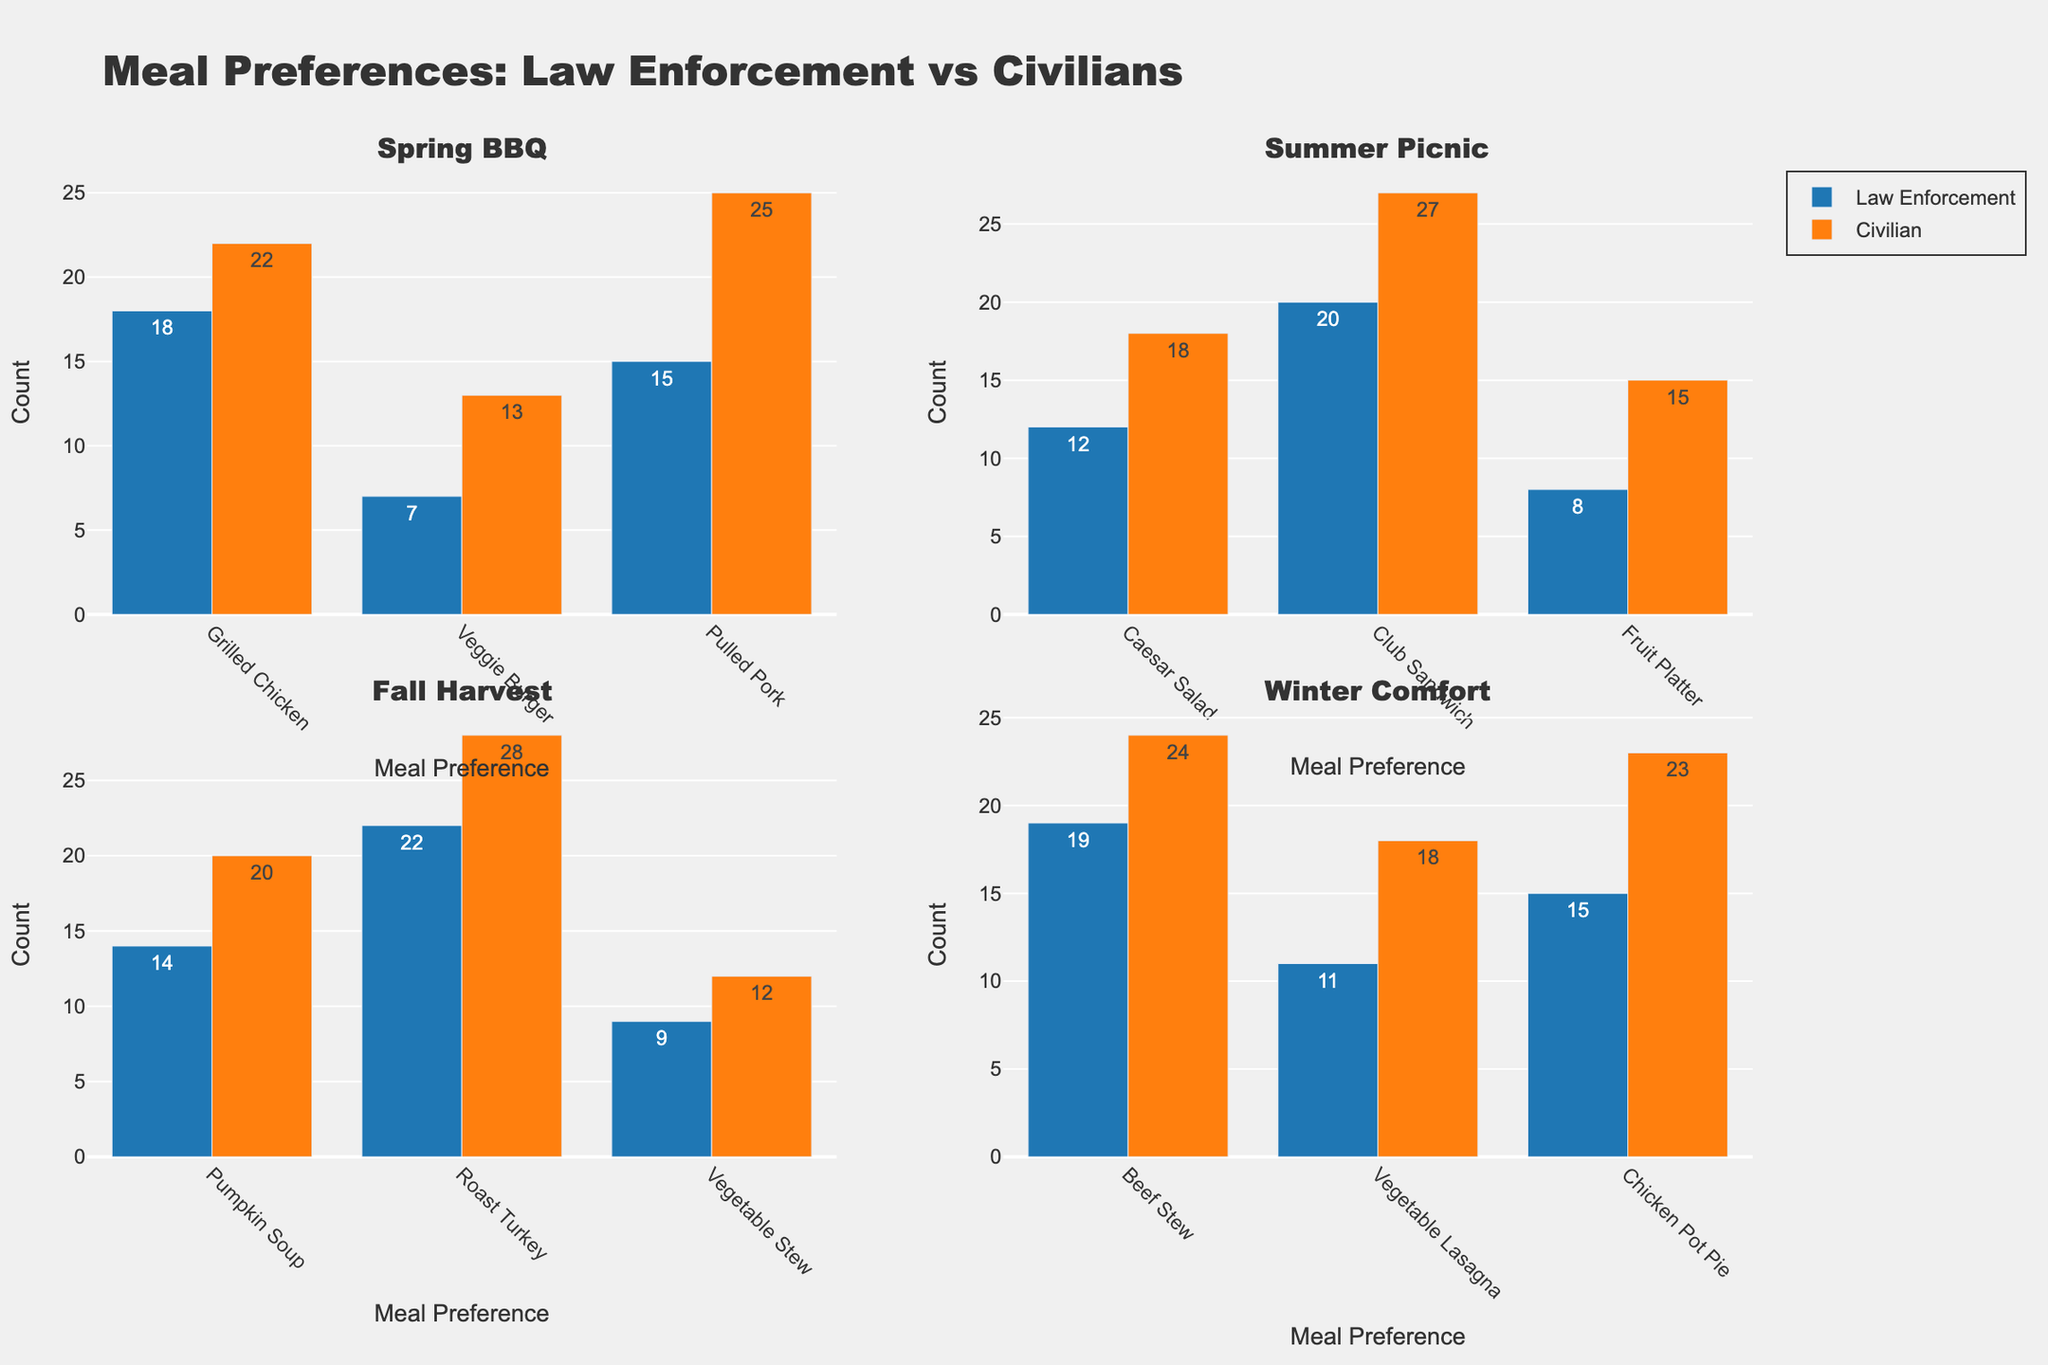What meal preference is the most popular among law enforcement at the Spring BBQ? The bar representing the number of law enforcement who preferred Pulled Pork at the Spring BBQ is the highest.
Answer: Pulled Pork What meal preference do civilians prefer the least at the Summer Picnic? The bar representing the number of civilians who preferred Fruit Platter at the Summer Picnic is the shortest.
Answer: Fruit Platter How many more civilians preferred Veggie Burger over law enforcement at the Spring BBQ? The bar for civilians' Veggie Burger preference at the Spring BBQ is 13, while the bar for law enforcement is 7. Subtract the two values: 13 - 7 = 6.
Answer: 6 Which category preferred Roast Turkey more during the Fall Harvest event? Compare the bars for Roast Turkey in the Fall Harvest event. Civilians have a higher count (28) than law enforcement (22).
Answer: Civilians During the Winter Comfort event, is the sum of civilians' preferences for Beef Stew and Chicken Pot Pie higher than the sum of law enforcement's preferences for the same meals? Civilians' preferences for Beef Stew and Chicken Pot Pie total 24 + 23 = 47. Law enforcement's preferences for the same meals total 19 + 15 = 34. 47 > 34.
Answer: Yes What is the total number of law enforcement who preferred Caesar Salad across all events? Caesar Salad preference is only listed under the Summer Picnic event where law enforcement count is 12.
Answer: 12 Which event had the highest count for a single meal preference category among civilians? Compare the highest meal preference counts among civilians across all events: Spring BBQ (Pulled Pork - 25), Summer Picnic (Club Sandwich - 27), Fall Harvest (Roast Turkey - 28), Winter Comfort (Beef Stew - 24). The highest value is 28 for Roast Turkey in the Fall Harvest.
Answer: Fall Harvest Do more civilians prefer grilled chicken or veggie burger at the Spring BBQ? Compare the bars for civilians' preference at the Spring BBQ, grilled chicken (22) and veggie burger (13). Grilled chicken has a higher count.
Answer: Grilled Chicken Which meal preference had a higher count for law enforcement than civilians during the Winter Comfort event? Compare the bars for Winter Comfort event preferences. None of the preferences have a higher count for law enforcement (Beef Stew, Vegetable Lasagna, Chicken Pot Pie) since all bars for law enforcement are shorter than civilians'.
Answer: None What is the overall trend in favorite meals for civilians across the events? Civilians tend to favor more substantial meals like Pulled Pork (25), Club Sandwich (27), Roast Turkey (28), and Beef Stew (24), which dominates their preference in different events.
Answer: Substantial Meals 